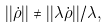<formula> <loc_0><loc_0><loc_500><loc_500>| | \dot { \rho } | | \ne | | \lambda \dot { \rho } | | / \lambda ,</formula> 